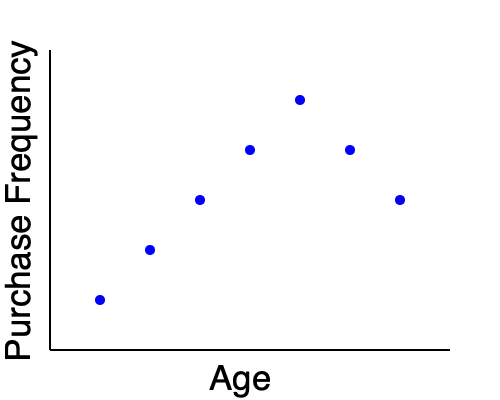Based on the scatter plot showing the relationship between customer age and purchase frequency, what trend can be observed, and how might this information be used to refine campaign targets? To interpret this scatter plot and determine how it can be used to refine campaign targets, let's follow these steps:

1. Observe the overall trend:
   The scatter plot shows a general negative correlation between age and purchase frequency. As age increases (moving right on the x-axis), purchase frequency tends to decrease (moving down on the y-axis).

2. Identify the peak:
   The highest purchase frequency appears to be among younger customers, with the peak occurring around the second or third data point from the left.

3. Note the exception:
   There's a slight uptick in purchase frequency for the oldest age group (rightmost data point), breaking the overall downward trend.

4. Interpret the data:
   - Younger customers tend to make more frequent purchases.
   - Middle-aged customers show a steady decline in purchase frequency.
   - The oldest customer group shows a slight increase in purchase frequency compared to the immediately younger group.

5. Apply to campaign targeting:
   - Focus primary marketing efforts on younger demographics, as they show the highest purchase frequency.
   - Create separate campaigns for middle-aged and older customers, taking into account their different purchasing behaviors.
   - Investigate why the oldest age group shows increased purchase frequency and potentially create targeted campaigns to capitalize on this trend.

6. Refine campaign strategies:
   - For younger customers: Emphasize frequent, trendy, or impulse purchases.
   - For middle-aged customers: Focus on quality and value propositions to encourage more frequent purchases.
   - For older customers: Explore loyalty programs or specialized products that cater to their needs and purchasing habits.

By using this data to inform campaign targeting, the marketing team can create more effective, age-specific strategies to increase overall purchase frequency across all demographics.
Answer: Negative correlation between age and purchase frequency; target younger demographics for frequent purchases, adjust strategies for middle-aged and older customers based on their distinct patterns. 